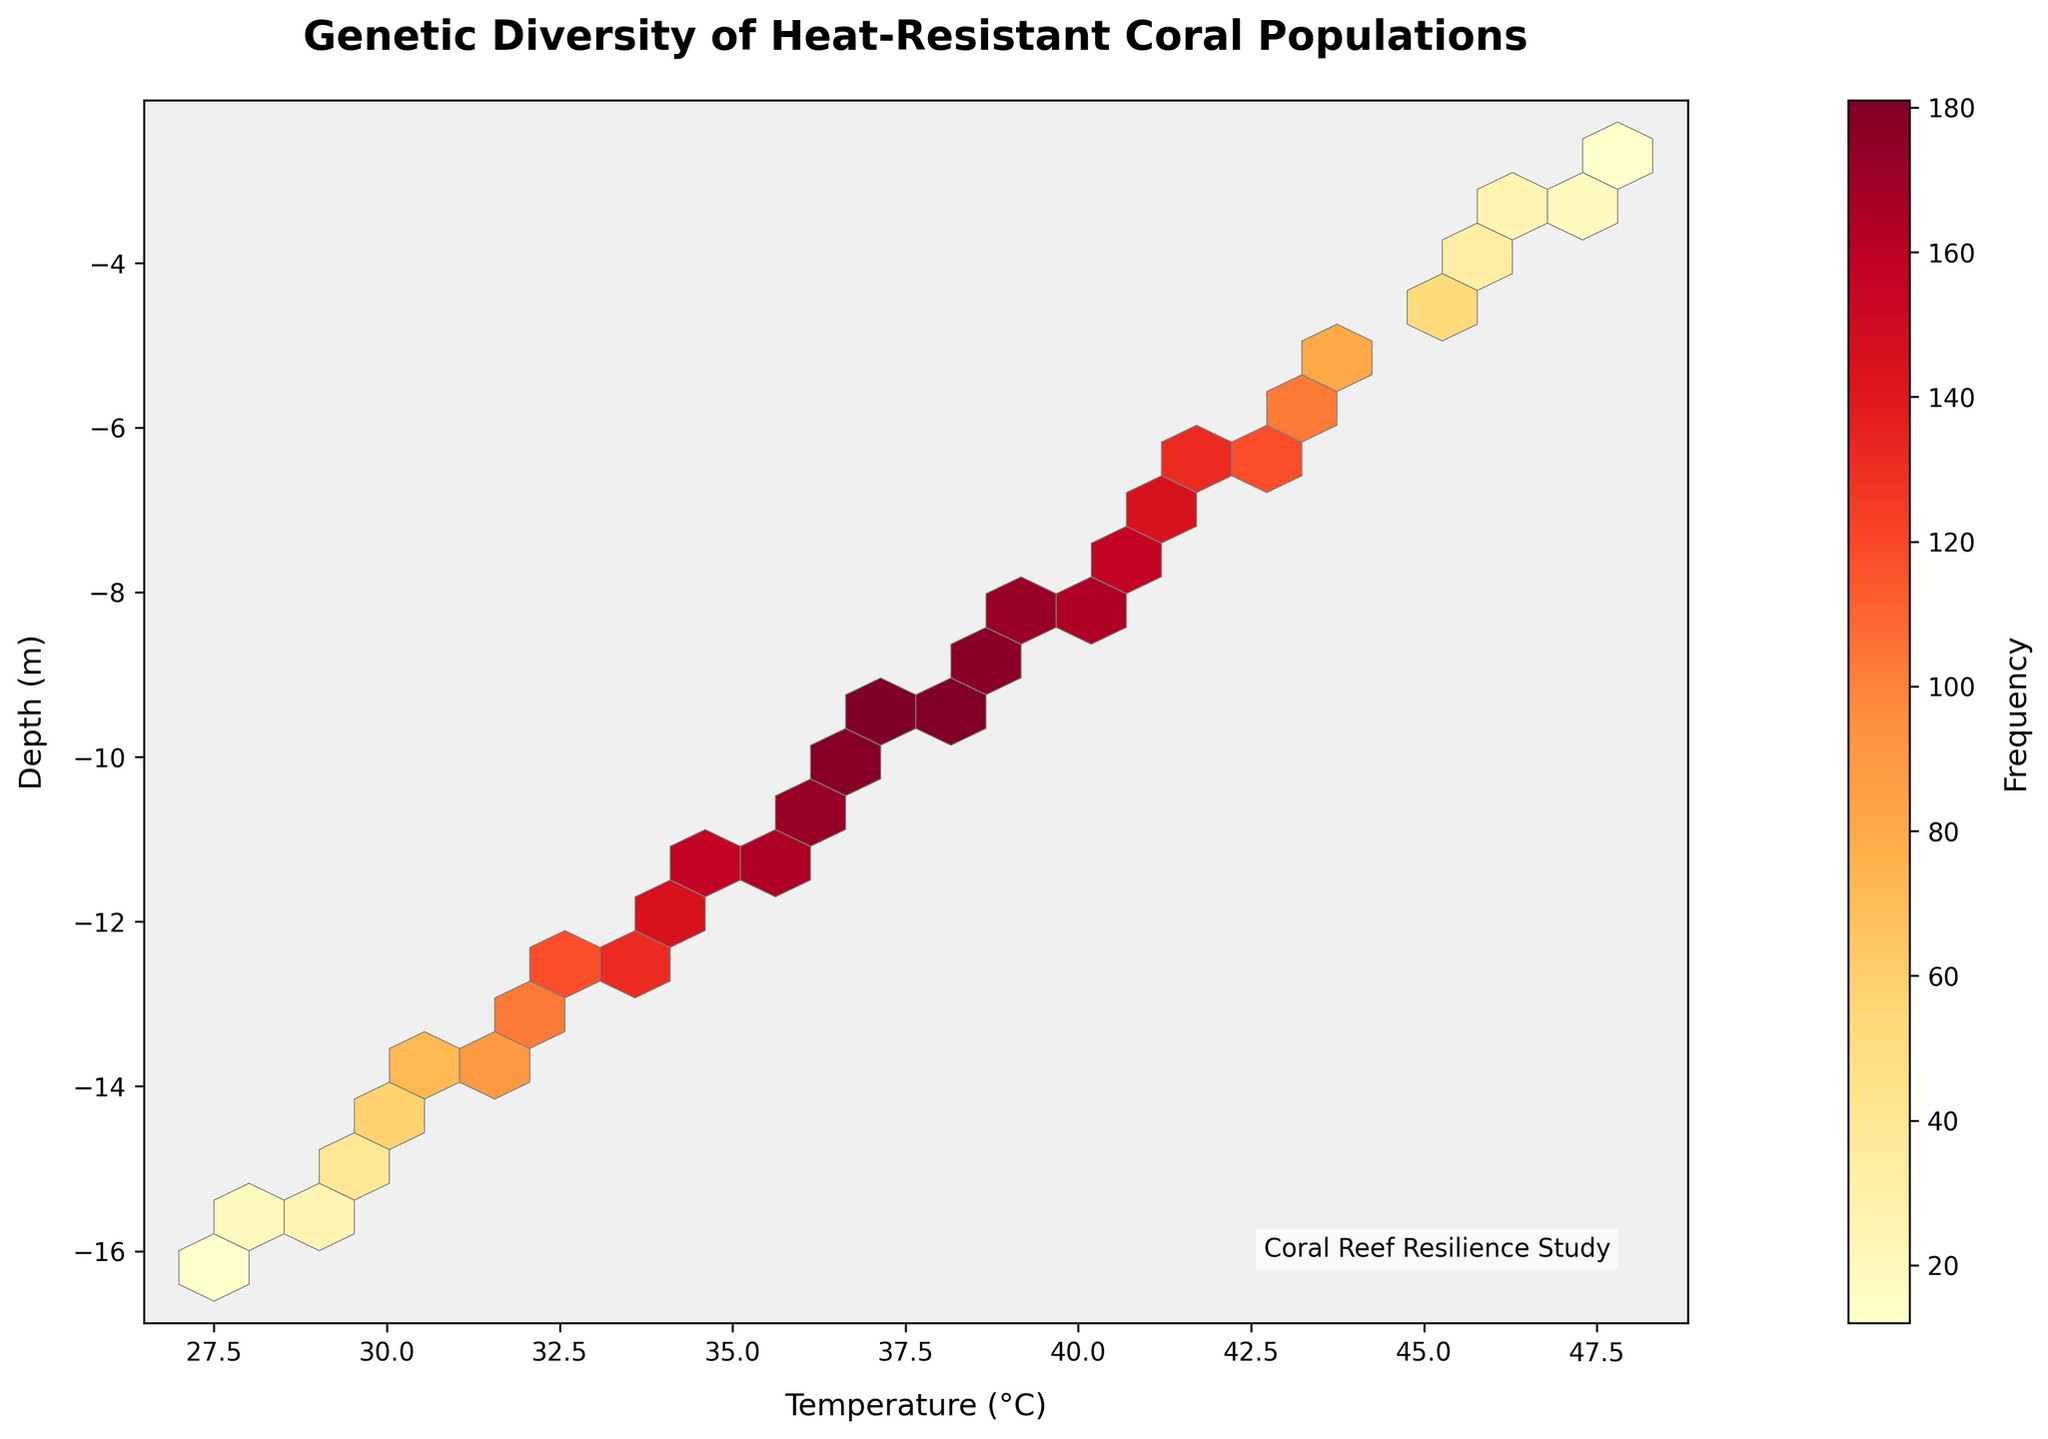What is the title of the plot? The title of the plot can be found at the top of the figure. Here it reads "Genetic Diversity of Heat-Resistant Coral Populations".
Answer: Genetic Diversity of Heat-Resistant Coral Populations What do the x-axis and y-axis represent? The x-axis label can be found at the bottom and it reads "Temperature (°C)", indicating it represents temperature. The y-axis label reads "Depth (m)", indicating it represents depth.
Answer: Temperature (°C) and Depth (m) What does the color scale represent in the plot? The color scale, found on the right side of the plot, has a label "Frequency". This means that the color represents the frequency of data points in each hexbin.
Answer: Frequency Between which temperature range is the highest frequency of the genetic diversity found? Observing the hexbin plot, the highest frequency occurs around the x-values between 37°C and 38°C, which is where the plot appears the most dense and has the brightest colors.
Answer: 37°C to 38°C What depth corresponds to the highest frequency of genetic diversity? By tracing vertically from the brightest hexbin (highest frequency), we see that this occurs around the depth of -9.5 meters.
Answer: -9.5 meters How does the frequency change as the temperature increases from 27.5°C to 31.0°C? Observing the plot from left (27.5°C) to right (31.0°C), the frequency increases gradually, as indicated by progressively brighter colors up to this temperature range.
Answer: The frequency increases What is the trend of genetic diversity frequency with increasing depth at a constant temperature of 39.4°C? Tracing vertically at a constant temperature of 39.4°C, we see that the frequency decreases with increasing depth, as the color becomes less intense.
Answer: It decreases Compare the genetic diversity frequency at temperatures 29.8°C and 40.0°C. Which is higher? Comparing the colors of the hexbins at 29.8°C and 40.0°C, the hexbin at 29.8°C is brighter, indicating it has a higher frequency of genetic diversity.
Answer: 29.8°C What is the unique feature of this hexbin plot compared to other plot types? A hexbin plot, unlike scatter or bar plots, groups data points into hexagonal bins and uses color intensity to represent the frequency within each bin, making it particularly useful for visualizing the density of large datasets.
Answer: Hexagonal bins represent frequency 